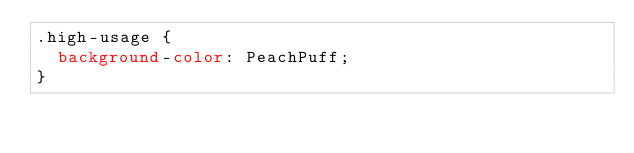<code> <loc_0><loc_0><loc_500><loc_500><_CSS_>.high-usage {
  background-color: PeachPuff;
}
</code> 